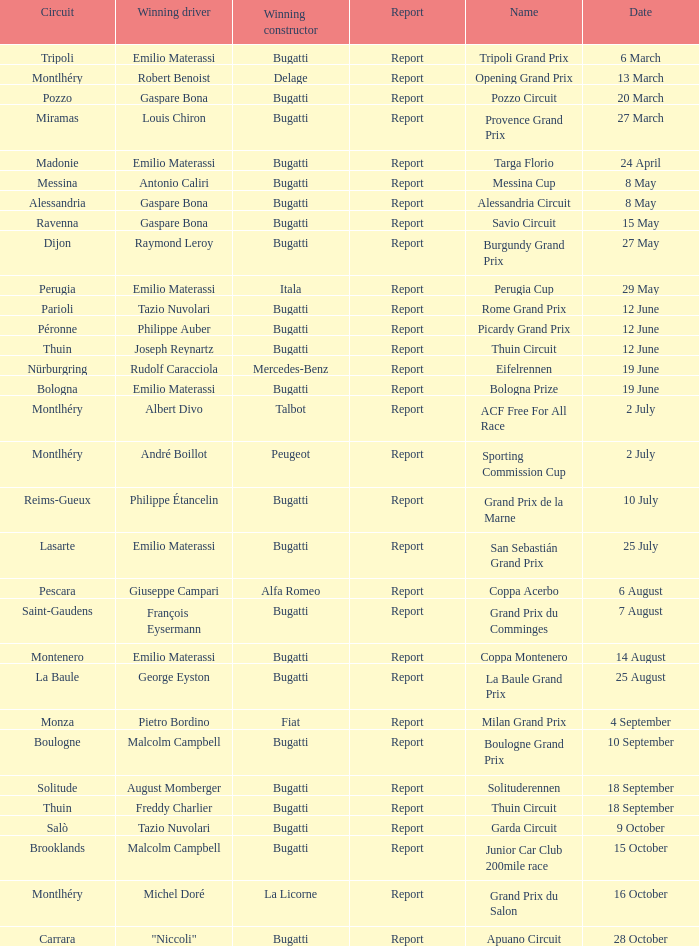Which circuit did françois eysermann win ? Saint-Gaudens. 